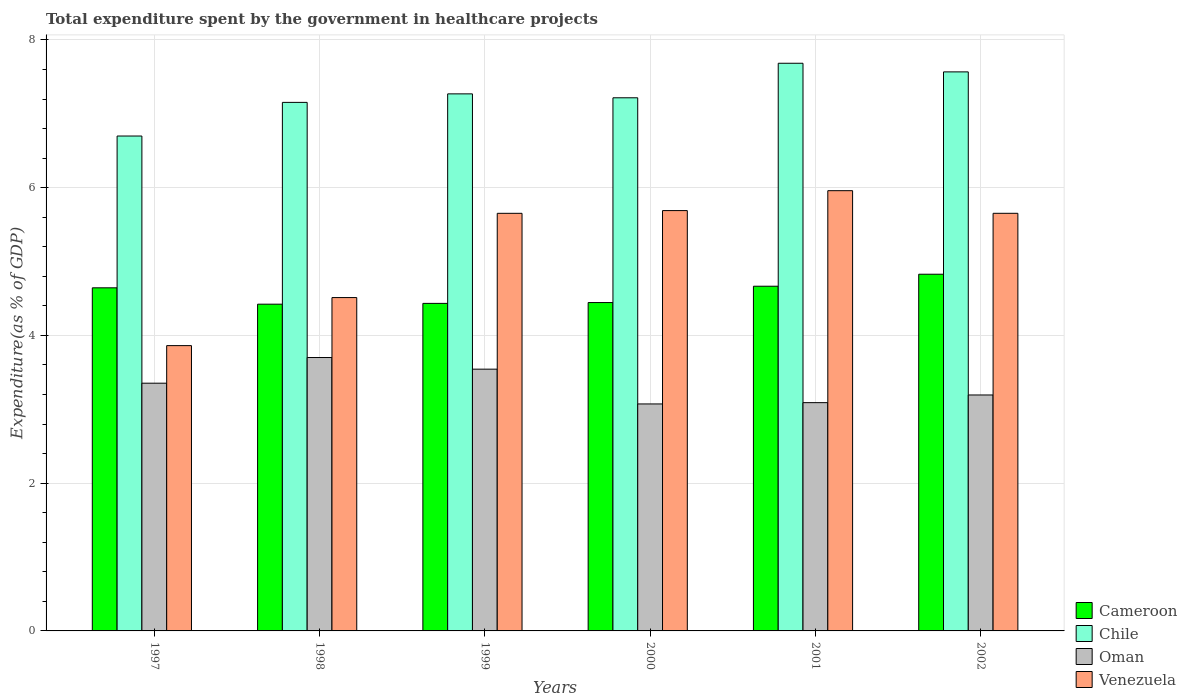How many different coloured bars are there?
Ensure brevity in your answer.  4. How many groups of bars are there?
Keep it short and to the point. 6. Are the number of bars on each tick of the X-axis equal?
Your response must be concise. Yes. How many bars are there on the 6th tick from the left?
Offer a very short reply. 4. In how many cases, is the number of bars for a given year not equal to the number of legend labels?
Keep it short and to the point. 0. What is the total expenditure spent by the government in healthcare projects in Chile in 1997?
Keep it short and to the point. 6.7. Across all years, what is the maximum total expenditure spent by the government in healthcare projects in Chile?
Make the answer very short. 7.68. Across all years, what is the minimum total expenditure spent by the government in healthcare projects in Venezuela?
Ensure brevity in your answer.  3.86. In which year was the total expenditure spent by the government in healthcare projects in Oman maximum?
Give a very brief answer. 1998. What is the total total expenditure spent by the government in healthcare projects in Chile in the graph?
Make the answer very short. 43.6. What is the difference between the total expenditure spent by the government in healthcare projects in Oman in 1998 and that in 2000?
Your answer should be compact. 0.63. What is the difference between the total expenditure spent by the government in healthcare projects in Chile in 2000 and the total expenditure spent by the government in healthcare projects in Oman in 1999?
Your answer should be very brief. 3.67. What is the average total expenditure spent by the government in healthcare projects in Chile per year?
Your answer should be compact. 7.27. In the year 2002, what is the difference between the total expenditure spent by the government in healthcare projects in Chile and total expenditure spent by the government in healthcare projects in Oman?
Provide a succinct answer. 4.37. In how many years, is the total expenditure spent by the government in healthcare projects in Chile greater than 1.2000000000000002 %?
Make the answer very short. 6. What is the ratio of the total expenditure spent by the government in healthcare projects in Venezuela in 1998 to that in 1999?
Give a very brief answer. 0.8. What is the difference between the highest and the second highest total expenditure spent by the government in healthcare projects in Chile?
Offer a terse response. 0.12. What is the difference between the highest and the lowest total expenditure spent by the government in healthcare projects in Venezuela?
Make the answer very short. 2.1. In how many years, is the total expenditure spent by the government in healthcare projects in Chile greater than the average total expenditure spent by the government in healthcare projects in Chile taken over all years?
Offer a very short reply. 3. Is it the case that in every year, the sum of the total expenditure spent by the government in healthcare projects in Venezuela and total expenditure spent by the government in healthcare projects in Cameroon is greater than the sum of total expenditure spent by the government in healthcare projects in Oman and total expenditure spent by the government in healthcare projects in Chile?
Offer a very short reply. Yes. What does the 4th bar from the left in 1997 represents?
Provide a short and direct response. Venezuela. What does the 3rd bar from the right in 2000 represents?
Make the answer very short. Chile. Is it the case that in every year, the sum of the total expenditure spent by the government in healthcare projects in Oman and total expenditure spent by the government in healthcare projects in Chile is greater than the total expenditure spent by the government in healthcare projects in Venezuela?
Make the answer very short. Yes. How many bars are there?
Keep it short and to the point. 24. What is the difference between two consecutive major ticks on the Y-axis?
Your response must be concise. 2. Are the values on the major ticks of Y-axis written in scientific E-notation?
Your response must be concise. No. Does the graph contain grids?
Offer a terse response. Yes. How are the legend labels stacked?
Give a very brief answer. Vertical. What is the title of the graph?
Your response must be concise. Total expenditure spent by the government in healthcare projects. Does "Portugal" appear as one of the legend labels in the graph?
Make the answer very short. No. What is the label or title of the Y-axis?
Keep it short and to the point. Expenditure(as % of GDP). What is the Expenditure(as % of GDP) of Cameroon in 1997?
Your answer should be very brief. 4.64. What is the Expenditure(as % of GDP) of Chile in 1997?
Offer a very short reply. 6.7. What is the Expenditure(as % of GDP) in Oman in 1997?
Provide a succinct answer. 3.35. What is the Expenditure(as % of GDP) of Venezuela in 1997?
Your answer should be very brief. 3.86. What is the Expenditure(as % of GDP) of Cameroon in 1998?
Ensure brevity in your answer.  4.42. What is the Expenditure(as % of GDP) in Chile in 1998?
Ensure brevity in your answer.  7.16. What is the Expenditure(as % of GDP) of Oman in 1998?
Provide a short and direct response. 3.7. What is the Expenditure(as % of GDP) of Venezuela in 1998?
Make the answer very short. 4.51. What is the Expenditure(as % of GDP) in Cameroon in 1999?
Offer a terse response. 4.43. What is the Expenditure(as % of GDP) in Chile in 1999?
Ensure brevity in your answer.  7.27. What is the Expenditure(as % of GDP) of Oman in 1999?
Offer a terse response. 3.54. What is the Expenditure(as % of GDP) in Venezuela in 1999?
Ensure brevity in your answer.  5.65. What is the Expenditure(as % of GDP) of Cameroon in 2000?
Keep it short and to the point. 4.45. What is the Expenditure(as % of GDP) in Chile in 2000?
Provide a short and direct response. 7.22. What is the Expenditure(as % of GDP) of Oman in 2000?
Ensure brevity in your answer.  3.07. What is the Expenditure(as % of GDP) of Venezuela in 2000?
Offer a very short reply. 5.69. What is the Expenditure(as % of GDP) of Cameroon in 2001?
Provide a short and direct response. 4.67. What is the Expenditure(as % of GDP) of Chile in 2001?
Your answer should be very brief. 7.68. What is the Expenditure(as % of GDP) in Oman in 2001?
Offer a terse response. 3.09. What is the Expenditure(as % of GDP) in Venezuela in 2001?
Your answer should be compact. 5.96. What is the Expenditure(as % of GDP) in Cameroon in 2002?
Make the answer very short. 4.83. What is the Expenditure(as % of GDP) in Chile in 2002?
Your response must be concise. 7.57. What is the Expenditure(as % of GDP) of Oman in 2002?
Provide a short and direct response. 3.19. What is the Expenditure(as % of GDP) of Venezuela in 2002?
Offer a terse response. 5.65. Across all years, what is the maximum Expenditure(as % of GDP) in Cameroon?
Provide a short and direct response. 4.83. Across all years, what is the maximum Expenditure(as % of GDP) in Chile?
Provide a succinct answer. 7.68. Across all years, what is the maximum Expenditure(as % of GDP) of Oman?
Your answer should be compact. 3.7. Across all years, what is the maximum Expenditure(as % of GDP) in Venezuela?
Your answer should be very brief. 5.96. Across all years, what is the minimum Expenditure(as % of GDP) in Cameroon?
Your answer should be very brief. 4.42. Across all years, what is the minimum Expenditure(as % of GDP) in Chile?
Your answer should be compact. 6.7. Across all years, what is the minimum Expenditure(as % of GDP) of Oman?
Make the answer very short. 3.07. Across all years, what is the minimum Expenditure(as % of GDP) in Venezuela?
Your answer should be very brief. 3.86. What is the total Expenditure(as % of GDP) in Cameroon in the graph?
Your answer should be compact. 27.44. What is the total Expenditure(as % of GDP) of Chile in the graph?
Provide a succinct answer. 43.6. What is the total Expenditure(as % of GDP) in Oman in the graph?
Ensure brevity in your answer.  19.96. What is the total Expenditure(as % of GDP) of Venezuela in the graph?
Offer a very short reply. 31.33. What is the difference between the Expenditure(as % of GDP) of Cameroon in 1997 and that in 1998?
Keep it short and to the point. 0.22. What is the difference between the Expenditure(as % of GDP) of Chile in 1997 and that in 1998?
Offer a very short reply. -0.46. What is the difference between the Expenditure(as % of GDP) of Oman in 1997 and that in 1998?
Provide a succinct answer. -0.35. What is the difference between the Expenditure(as % of GDP) of Venezuela in 1997 and that in 1998?
Give a very brief answer. -0.65. What is the difference between the Expenditure(as % of GDP) of Cameroon in 1997 and that in 1999?
Your answer should be very brief. 0.21. What is the difference between the Expenditure(as % of GDP) in Chile in 1997 and that in 1999?
Make the answer very short. -0.57. What is the difference between the Expenditure(as % of GDP) of Oman in 1997 and that in 1999?
Give a very brief answer. -0.19. What is the difference between the Expenditure(as % of GDP) in Venezuela in 1997 and that in 1999?
Ensure brevity in your answer.  -1.79. What is the difference between the Expenditure(as % of GDP) of Cameroon in 1997 and that in 2000?
Give a very brief answer. 0.2. What is the difference between the Expenditure(as % of GDP) in Chile in 1997 and that in 2000?
Ensure brevity in your answer.  -0.52. What is the difference between the Expenditure(as % of GDP) in Oman in 1997 and that in 2000?
Give a very brief answer. 0.28. What is the difference between the Expenditure(as % of GDP) in Venezuela in 1997 and that in 2000?
Your answer should be very brief. -1.83. What is the difference between the Expenditure(as % of GDP) of Cameroon in 1997 and that in 2001?
Your answer should be compact. -0.02. What is the difference between the Expenditure(as % of GDP) in Chile in 1997 and that in 2001?
Make the answer very short. -0.99. What is the difference between the Expenditure(as % of GDP) of Oman in 1997 and that in 2001?
Your answer should be compact. 0.26. What is the difference between the Expenditure(as % of GDP) in Venezuela in 1997 and that in 2001?
Your answer should be very brief. -2.1. What is the difference between the Expenditure(as % of GDP) in Cameroon in 1997 and that in 2002?
Ensure brevity in your answer.  -0.18. What is the difference between the Expenditure(as % of GDP) in Chile in 1997 and that in 2002?
Your response must be concise. -0.87. What is the difference between the Expenditure(as % of GDP) of Oman in 1997 and that in 2002?
Your answer should be very brief. 0.16. What is the difference between the Expenditure(as % of GDP) in Venezuela in 1997 and that in 2002?
Offer a terse response. -1.79. What is the difference between the Expenditure(as % of GDP) in Cameroon in 1998 and that in 1999?
Provide a short and direct response. -0.01. What is the difference between the Expenditure(as % of GDP) in Chile in 1998 and that in 1999?
Provide a succinct answer. -0.12. What is the difference between the Expenditure(as % of GDP) in Oman in 1998 and that in 1999?
Make the answer very short. 0.16. What is the difference between the Expenditure(as % of GDP) of Venezuela in 1998 and that in 1999?
Give a very brief answer. -1.14. What is the difference between the Expenditure(as % of GDP) of Cameroon in 1998 and that in 2000?
Give a very brief answer. -0.02. What is the difference between the Expenditure(as % of GDP) in Chile in 1998 and that in 2000?
Your response must be concise. -0.06. What is the difference between the Expenditure(as % of GDP) of Oman in 1998 and that in 2000?
Your response must be concise. 0.63. What is the difference between the Expenditure(as % of GDP) in Venezuela in 1998 and that in 2000?
Provide a succinct answer. -1.18. What is the difference between the Expenditure(as % of GDP) of Cameroon in 1998 and that in 2001?
Make the answer very short. -0.24. What is the difference between the Expenditure(as % of GDP) in Chile in 1998 and that in 2001?
Keep it short and to the point. -0.53. What is the difference between the Expenditure(as % of GDP) in Oman in 1998 and that in 2001?
Your answer should be very brief. 0.61. What is the difference between the Expenditure(as % of GDP) of Venezuela in 1998 and that in 2001?
Offer a terse response. -1.45. What is the difference between the Expenditure(as % of GDP) of Cameroon in 1998 and that in 2002?
Offer a very short reply. -0.41. What is the difference between the Expenditure(as % of GDP) in Chile in 1998 and that in 2002?
Offer a terse response. -0.41. What is the difference between the Expenditure(as % of GDP) in Oman in 1998 and that in 2002?
Offer a terse response. 0.51. What is the difference between the Expenditure(as % of GDP) in Venezuela in 1998 and that in 2002?
Make the answer very short. -1.14. What is the difference between the Expenditure(as % of GDP) of Cameroon in 1999 and that in 2000?
Give a very brief answer. -0.01. What is the difference between the Expenditure(as % of GDP) of Chile in 1999 and that in 2000?
Provide a succinct answer. 0.05. What is the difference between the Expenditure(as % of GDP) of Oman in 1999 and that in 2000?
Provide a succinct answer. 0.47. What is the difference between the Expenditure(as % of GDP) of Venezuela in 1999 and that in 2000?
Give a very brief answer. -0.04. What is the difference between the Expenditure(as % of GDP) in Cameroon in 1999 and that in 2001?
Give a very brief answer. -0.23. What is the difference between the Expenditure(as % of GDP) of Chile in 1999 and that in 2001?
Provide a short and direct response. -0.41. What is the difference between the Expenditure(as % of GDP) of Oman in 1999 and that in 2001?
Your answer should be compact. 0.45. What is the difference between the Expenditure(as % of GDP) of Venezuela in 1999 and that in 2001?
Keep it short and to the point. -0.31. What is the difference between the Expenditure(as % of GDP) of Cameroon in 1999 and that in 2002?
Your answer should be compact. -0.39. What is the difference between the Expenditure(as % of GDP) in Chile in 1999 and that in 2002?
Provide a succinct answer. -0.3. What is the difference between the Expenditure(as % of GDP) in Oman in 1999 and that in 2002?
Your answer should be very brief. 0.35. What is the difference between the Expenditure(as % of GDP) of Venezuela in 1999 and that in 2002?
Make the answer very short. -0. What is the difference between the Expenditure(as % of GDP) of Cameroon in 2000 and that in 2001?
Provide a short and direct response. -0.22. What is the difference between the Expenditure(as % of GDP) of Chile in 2000 and that in 2001?
Provide a short and direct response. -0.47. What is the difference between the Expenditure(as % of GDP) in Oman in 2000 and that in 2001?
Give a very brief answer. -0.02. What is the difference between the Expenditure(as % of GDP) of Venezuela in 2000 and that in 2001?
Your response must be concise. -0.27. What is the difference between the Expenditure(as % of GDP) in Cameroon in 2000 and that in 2002?
Your answer should be very brief. -0.38. What is the difference between the Expenditure(as % of GDP) of Chile in 2000 and that in 2002?
Keep it short and to the point. -0.35. What is the difference between the Expenditure(as % of GDP) of Oman in 2000 and that in 2002?
Offer a very short reply. -0.12. What is the difference between the Expenditure(as % of GDP) in Venezuela in 2000 and that in 2002?
Ensure brevity in your answer.  0.04. What is the difference between the Expenditure(as % of GDP) in Cameroon in 2001 and that in 2002?
Offer a very short reply. -0.16. What is the difference between the Expenditure(as % of GDP) in Chile in 2001 and that in 2002?
Make the answer very short. 0.12. What is the difference between the Expenditure(as % of GDP) of Oman in 2001 and that in 2002?
Offer a very short reply. -0.1. What is the difference between the Expenditure(as % of GDP) of Venezuela in 2001 and that in 2002?
Ensure brevity in your answer.  0.31. What is the difference between the Expenditure(as % of GDP) in Cameroon in 1997 and the Expenditure(as % of GDP) in Chile in 1998?
Your response must be concise. -2.51. What is the difference between the Expenditure(as % of GDP) of Cameroon in 1997 and the Expenditure(as % of GDP) of Oman in 1998?
Ensure brevity in your answer.  0.94. What is the difference between the Expenditure(as % of GDP) in Cameroon in 1997 and the Expenditure(as % of GDP) in Venezuela in 1998?
Make the answer very short. 0.13. What is the difference between the Expenditure(as % of GDP) in Chile in 1997 and the Expenditure(as % of GDP) in Oman in 1998?
Keep it short and to the point. 3. What is the difference between the Expenditure(as % of GDP) of Chile in 1997 and the Expenditure(as % of GDP) of Venezuela in 1998?
Ensure brevity in your answer.  2.19. What is the difference between the Expenditure(as % of GDP) in Oman in 1997 and the Expenditure(as % of GDP) in Venezuela in 1998?
Offer a very short reply. -1.16. What is the difference between the Expenditure(as % of GDP) of Cameroon in 1997 and the Expenditure(as % of GDP) of Chile in 1999?
Offer a terse response. -2.63. What is the difference between the Expenditure(as % of GDP) of Cameroon in 1997 and the Expenditure(as % of GDP) of Oman in 1999?
Keep it short and to the point. 1.1. What is the difference between the Expenditure(as % of GDP) of Cameroon in 1997 and the Expenditure(as % of GDP) of Venezuela in 1999?
Provide a succinct answer. -1.01. What is the difference between the Expenditure(as % of GDP) of Chile in 1997 and the Expenditure(as % of GDP) of Oman in 1999?
Give a very brief answer. 3.16. What is the difference between the Expenditure(as % of GDP) in Chile in 1997 and the Expenditure(as % of GDP) in Venezuela in 1999?
Your answer should be very brief. 1.05. What is the difference between the Expenditure(as % of GDP) of Oman in 1997 and the Expenditure(as % of GDP) of Venezuela in 1999?
Ensure brevity in your answer.  -2.3. What is the difference between the Expenditure(as % of GDP) in Cameroon in 1997 and the Expenditure(as % of GDP) in Chile in 2000?
Ensure brevity in your answer.  -2.57. What is the difference between the Expenditure(as % of GDP) in Cameroon in 1997 and the Expenditure(as % of GDP) in Oman in 2000?
Give a very brief answer. 1.57. What is the difference between the Expenditure(as % of GDP) in Cameroon in 1997 and the Expenditure(as % of GDP) in Venezuela in 2000?
Offer a very short reply. -1.05. What is the difference between the Expenditure(as % of GDP) of Chile in 1997 and the Expenditure(as % of GDP) of Oman in 2000?
Keep it short and to the point. 3.63. What is the difference between the Expenditure(as % of GDP) in Chile in 1997 and the Expenditure(as % of GDP) in Venezuela in 2000?
Your response must be concise. 1.01. What is the difference between the Expenditure(as % of GDP) in Oman in 1997 and the Expenditure(as % of GDP) in Venezuela in 2000?
Offer a very short reply. -2.34. What is the difference between the Expenditure(as % of GDP) of Cameroon in 1997 and the Expenditure(as % of GDP) of Chile in 2001?
Offer a terse response. -3.04. What is the difference between the Expenditure(as % of GDP) of Cameroon in 1997 and the Expenditure(as % of GDP) of Oman in 2001?
Your answer should be very brief. 1.55. What is the difference between the Expenditure(as % of GDP) of Cameroon in 1997 and the Expenditure(as % of GDP) of Venezuela in 2001?
Provide a short and direct response. -1.32. What is the difference between the Expenditure(as % of GDP) of Chile in 1997 and the Expenditure(as % of GDP) of Oman in 2001?
Your answer should be compact. 3.61. What is the difference between the Expenditure(as % of GDP) in Chile in 1997 and the Expenditure(as % of GDP) in Venezuela in 2001?
Ensure brevity in your answer.  0.74. What is the difference between the Expenditure(as % of GDP) in Oman in 1997 and the Expenditure(as % of GDP) in Venezuela in 2001?
Provide a succinct answer. -2.61. What is the difference between the Expenditure(as % of GDP) in Cameroon in 1997 and the Expenditure(as % of GDP) in Chile in 2002?
Your response must be concise. -2.92. What is the difference between the Expenditure(as % of GDP) of Cameroon in 1997 and the Expenditure(as % of GDP) of Oman in 2002?
Offer a very short reply. 1.45. What is the difference between the Expenditure(as % of GDP) in Cameroon in 1997 and the Expenditure(as % of GDP) in Venezuela in 2002?
Make the answer very short. -1.01. What is the difference between the Expenditure(as % of GDP) of Chile in 1997 and the Expenditure(as % of GDP) of Oman in 2002?
Your answer should be very brief. 3.51. What is the difference between the Expenditure(as % of GDP) of Chile in 1997 and the Expenditure(as % of GDP) of Venezuela in 2002?
Your response must be concise. 1.05. What is the difference between the Expenditure(as % of GDP) in Oman in 1997 and the Expenditure(as % of GDP) in Venezuela in 2002?
Provide a succinct answer. -2.3. What is the difference between the Expenditure(as % of GDP) of Cameroon in 1998 and the Expenditure(as % of GDP) of Chile in 1999?
Your answer should be very brief. -2.85. What is the difference between the Expenditure(as % of GDP) in Cameroon in 1998 and the Expenditure(as % of GDP) in Oman in 1999?
Provide a succinct answer. 0.88. What is the difference between the Expenditure(as % of GDP) in Cameroon in 1998 and the Expenditure(as % of GDP) in Venezuela in 1999?
Offer a terse response. -1.23. What is the difference between the Expenditure(as % of GDP) in Chile in 1998 and the Expenditure(as % of GDP) in Oman in 1999?
Keep it short and to the point. 3.61. What is the difference between the Expenditure(as % of GDP) of Chile in 1998 and the Expenditure(as % of GDP) of Venezuela in 1999?
Your answer should be compact. 1.5. What is the difference between the Expenditure(as % of GDP) in Oman in 1998 and the Expenditure(as % of GDP) in Venezuela in 1999?
Make the answer very short. -1.95. What is the difference between the Expenditure(as % of GDP) in Cameroon in 1998 and the Expenditure(as % of GDP) in Chile in 2000?
Your answer should be very brief. -2.79. What is the difference between the Expenditure(as % of GDP) of Cameroon in 1998 and the Expenditure(as % of GDP) of Oman in 2000?
Your answer should be compact. 1.35. What is the difference between the Expenditure(as % of GDP) in Cameroon in 1998 and the Expenditure(as % of GDP) in Venezuela in 2000?
Offer a terse response. -1.27. What is the difference between the Expenditure(as % of GDP) in Chile in 1998 and the Expenditure(as % of GDP) in Oman in 2000?
Offer a very short reply. 4.08. What is the difference between the Expenditure(as % of GDP) in Chile in 1998 and the Expenditure(as % of GDP) in Venezuela in 2000?
Offer a very short reply. 1.46. What is the difference between the Expenditure(as % of GDP) of Oman in 1998 and the Expenditure(as % of GDP) of Venezuela in 2000?
Your response must be concise. -1.99. What is the difference between the Expenditure(as % of GDP) of Cameroon in 1998 and the Expenditure(as % of GDP) of Chile in 2001?
Offer a very short reply. -3.26. What is the difference between the Expenditure(as % of GDP) in Cameroon in 1998 and the Expenditure(as % of GDP) in Oman in 2001?
Make the answer very short. 1.33. What is the difference between the Expenditure(as % of GDP) of Cameroon in 1998 and the Expenditure(as % of GDP) of Venezuela in 2001?
Offer a very short reply. -1.54. What is the difference between the Expenditure(as % of GDP) of Chile in 1998 and the Expenditure(as % of GDP) of Oman in 2001?
Your answer should be compact. 4.06. What is the difference between the Expenditure(as % of GDP) in Chile in 1998 and the Expenditure(as % of GDP) in Venezuela in 2001?
Your answer should be compact. 1.2. What is the difference between the Expenditure(as % of GDP) of Oman in 1998 and the Expenditure(as % of GDP) of Venezuela in 2001?
Ensure brevity in your answer.  -2.26. What is the difference between the Expenditure(as % of GDP) of Cameroon in 1998 and the Expenditure(as % of GDP) of Chile in 2002?
Keep it short and to the point. -3.14. What is the difference between the Expenditure(as % of GDP) of Cameroon in 1998 and the Expenditure(as % of GDP) of Oman in 2002?
Offer a very short reply. 1.23. What is the difference between the Expenditure(as % of GDP) of Cameroon in 1998 and the Expenditure(as % of GDP) of Venezuela in 2002?
Ensure brevity in your answer.  -1.23. What is the difference between the Expenditure(as % of GDP) of Chile in 1998 and the Expenditure(as % of GDP) of Oman in 2002?
Ensure brevity in your answer.  3.96. What is the difference between the Expenditure(as % of GDP) in Chile in 1998 and the Expenditure(as % of GDP) in Venezuela in 2002?
Your response must be concise. 1.5. What is the difference between the Expenditure(as % of GDP) of Oman in 1998 and the Expenditure(as % of GDP) of Venezuela in 2002?
Ensure brevity in your answer.  -1.95. What is the difference between the Expenditure(as % of GDP) of Cameroon in 1999 and the Expenditure(as % of GDP) of Chile in 2000?
Make the answer very short. -2.78. What is the difference between the Expenditure(as % of GDP) of Cameroon in 1999 and the Expenditure(as % of GDP) of Oman in 2000?
Offer a very short reply. 1.36. What is the difference between the Expenditure(as % of GDP) in Cameroon in 1999 and the Expenditure(as % of GDP) in Venezuela in 2000?
Your answer should be very brief. -1.26. What is the difference between the Expenditure(as % of GDP) in Chile in 1999 and the Expenditure(as % of GDP) in Oman in 2000?
Offer a very short reply. 4.2. What is the difference between the Expenditure(as % of GDP) of Chile in 1999 and the Expenditure(as % of GDP) of Venezuela in 2000?
Ensure brevity in your answer.  1.58. What is the difference between the Expenditure(as % of GDP) of Oman in 1999 and the Expenditure(as % of GDP) of Venezuela in 2000?
Your response must be concise. -2.15. What is the difference between the Expenditure(as % of GDP) in Cameroon in 1999 and the Expenditure(as % of GDP) in Chile in 2001?
Your answer should be very brief. -3.25. What is the difference between the Expenditure(as % of GDP) in Cameroon in 1999 and the Expenditure(as % of GDP) in Oman in 2001?
Keep it short and to the point. 1.34. What is the difference between the Expenditure(as % of GDP) in Cameroon in 1999 and the Expenditure(as % of GDP) in Venezuela in 2001?
Offer a terse response. -1.53. What is the difference between the Expenditure(as % of GDP) of Chile in 1999 and the Expenditure(as % of GDP) of Oman in 2001?
Offer a very short reply. 4.18. What is the difference between the Expenditure(as % of GDP) of Chile in 1999 and the Expenditure(as % of GDP) of Venezuela in 2001?
Provide a short and direct response. 1.31. What is the difference between the Expenditure(as % of GDP) of Oman in 1999 and the Expenditure(as % of GDP) of Venezuela in 2001?
Your response must be concise. -2.42. What is the difference between the Expenditure(as % of GDP) in Cameroon in 1999 and the Expenditure(as % of GDP) in Chile in 2002?
Ensure brevity in your answer.  -3.13. What is the difference between the Expenditure(as % of GDP) in Cameroon in 1999 and the Expenditure(as % of GDP) in Oman in 2002?
Give a very brief answer. 1.24. What is the difference between the Expenditure(as % of GDP) in Cameroon in 1999 and the Expenditure(as % of GDP) in Venezuela in 2002?
Keep it short and to the point. -1.22. What is the difference between the Expenditure(as % of GDP) of Chile in 1999 and the Expenditure(as % of GDP) of Oman in 2002?
Ensure brevity in your answer.  4.08. What is the difference between the Expenditure(as % of GDP) in Chile in 1999 and the Expenditure(as % of GDP) in Venezuela in 2002?
Your response must be concise. 1.62. What is the difference between the Expenditure(as % of GDP) of Oman in 1999 and the Expenditure(as % of GDP) of Venezuela in 2002?
Offer a terse response. -2.11. What is the difference between the Expenditure(as % of GDP) of Cameroon in 2000 and the Expenditure(as % of GDP) of Chile in 2001?
Offer a terse response. -3.24. What is the difference between the Expenditure(as % of GDP) in Cameroon in 2000 and the Expenditure(as % of GDP) in Oman in 2001?
Your answer should be very brief. 1.35. What is the difference between the Expenditure(as % of GDP) of Cameroon in 2000 and the Expenditure(as % of GDP) of Venezuela in 2001?
Offer a terse response. -1.51. What is the difference between the Expenditure(as % of GDP) of Chile in 2000 and the Expenditure(as % of GDP) of Oman in 2001?
Your response must be concise. 4.13. What is the difference between the Expenditure(as % of GDP) of Chile in 2000 and the Expenditure(as % of GDP) of Venezuela in 2001?
Your answer should be very brief. 1.26. What is the difference between the Expenditure(as % of GDP) of Oman in 2000 and the Expenditure(as % of GDP) of Venezuela in 2001?
Your answer should be very brief. -2.89. What is the difference between the Expenditure(as % of GDP) in Cameroon in 2000 and the Expenditure(as % of GDP) in Chile in 2002?
Provide a succinct answer. -3.12. What is the difference between the Expenditure(as % of GDP) of Cameroon in 2000 and the Expenditure(as % of GDP) of Oman in 2002?
Your response must be concise. 1.25. What is the difference between the Expenditure(as % of GDP) in Cameroon in 2000 and the Expenditure(as % of GDP) in Venezuela in 2002?
Provide a succinct answer. -1.21. What is the difference between the Expenditure(as % of GDP) in Chile in 2000 and the Expenditure(as % of GDP) in Oman in 2002?
Provide a short and direct response. 4.02. What is the difference between the Expenditure(as % of GDP) in Chile in 2000 and the Expenditure(as % of GDP) in Venezuela in 2002?
Ensure brevity in your answer.  1.56. What is the difference between the Expenditure(as % of GDP) in Oman in 2000 and the Expenditure(as % of GDP) in Venezuela in 2002?
Your answer should be very brief. -2.58. What is the difference between the Expenditure(as % of GDP) of Cameroon in 2001 and the Expenditure(as % of GDP) of Chile in 2002?
Your response must be concise. -2.9. What is the difference between the Expenditure(as % of GDP) of Cameroon in 2001 and the Expenditure(as % of GDP) of Oman in 2002?
Provide a succinct answer. 1.47. What is the difference between the Expenditure(as % of GDP) in Cameroon in 2001 and the Expenditure(as % of GDP) in Venezuela in 2002?
Your response must be concise. -0.99. What is the difference between the Expenditure(as % of GDP) in Chile in 2001 and the Expenditure(as % of GDP) in Oman in 2002?
Offer a very short reply. 4.49. What is the difference between the Expenditure(as % of GDP) in Chile in 2001 and the Expenditure(as % of GDP) in Venezuela in 2002?
Your answer should be very brief. 2.03. What is the difference between the Expenditure(as % of GDP) in Oman in 2001 and the Expenditure(as % of GDP) in Venezuela in 2002?
Give a very brief answer. -2.56. What is the average Expenditure(as % of GDP) in Cameroon per year?
Provide a succinct answer. 4.57. What is the average Expenditure(as % of GDP) of Chile per year?
Keep it short and to the point. 7.27. What is the average Expenditure(as % of GDP) of Oman per year?
Give a very brief answer. 3.33. What is the average Expenditure(as % of GDP) of Venezuela per year?
Offer a terse response. 5.22. In the year 1997, what is the difference between the Expenditure(as % of GDP) of Cameroon and Expenditure(as % of GDP) of Chile?
Your answer should be very brief. -2.06. In the year 1997, what is the difference between the Expenditure(as % of GDP) in Cameroon and Expenditure(as % of GDP) in Oman?
Make the answer very short. 1.29. In the year 1997, what is the difference between the Expenditure(as % of GDP) in Cameroon and Expenditure(as % of GDP) in Venezuela?
Offer a very short reply. 0.78. In the year 1997, what is the difference between the Expenditure(as % of GDP) of Chile and Expenditure(as % of GDP) of Oman?
Offer a very short reply. 3.35. In the year 1997, what is the difference between the Expenditure(as % of GDP) of Chile and Expenditure(as % of GDP) of Venezuela?
Provide a succinct answer. 2.84. In the year 1997, what is the difference between the Expenditure(as % of GDP) in Oman and Expenditure(as % of GDP) in Venezuela?
Ensure brevity in your answer.  -0.51. In the year 1998, what is the difference between the Expenditure(as % of GDP) in Cameroon and Expenditure(as % of GDP) in Chile?
Your answer should be compact. -2.73. In the year 1998, what is the difference between the Expenditure(as % of GDP) of Cameroon and Expenditure(as % of GDP) of Oman?
Give a very brief answer. 0.72. In the year 1998, what is the difference between the Expenditure(as % of GDP) of Cameroon and Expenditure(as % of GDP) of Venezuela?
Provide a succinct answer. -0.09. In the year 1998, what is the difference between the Expenditure(as % of GDP) in Chile and Expenditure(as % of GDP) in Oman?
Keep it short and to the point. 3.45. In the year 1998, what is the difference between the Expenditure(as % of GDP) of Chile and Expenditure(as % of GDP) of Venezuela?
Ensure brevity in your answer.  2.64. In the year 1998, what is the difference between the Expenditure(as % of GDP) in Oman and Expenditure(as % of GDP) in Venezuela?
Offer a very short reply. -0.81. In the year 1999, what is the difference between the Expenditure(as % of GDP) of Cameroon and Expenditure(as % of GDP) of Chile?
Your answer should be very brief. -2.84. In the year 1999, what is the difference between the Expenditure(as % of GDP) in Cameroon and Expenditure(as % of GDP) in Oman?
Your answer should be very brief. 0.89. In the year 1999, what is the difference between the Expenditure(as % of GDP) in Cameroon and Expenditure(as % of GDP) in Venezuela?
Give a very brief answer. -1.22. In the year 1999, what is the difference between the Expenditure(as % of GDP) in Chile and Expenditure(as % of GDP) in Oman?
Your response must be concise. 3.73. In the year 1999, what is the difference between the Expenditure(as % of GDP) of Chile and Expenditure(as % of GDP) of Venezuela?
Provide a succinct answer. 1.62. In the year 1999, what is the difference between the Expenditure(as % of GDP) of Oman and Expenditure(as % of GDP) of Venezuela?
Give a very brief answer. -2.11. In the year 2000, what is the difference between the Expenditure(as % of GDP) of Cameroon and Expenditure(as % of GDP) of Chile?
Provide a short and direct response. -2.77. In the year 2000, what is the difference between the Expenditure(as % of GDP) in Cameroon and Expenditure(as % of GDP) in Oman?
Provide a short and direct response. 1.37. In the year 2000, what is the difference between the Expenditure(as % of GDP) of Cameroon and Expenditure(as % of GDP) of Venezuela?
Provide a succinct answer. -1.25. In the year 2000, what is the difference between the Expenditure(as % of GDP) in Chile and Expenditure(as % of GDP) in Oman?
Provide a succinct answer. 4.14. In the year 2000, what is the difference between the Expenditure(as % of GDP) in Chile and Expenditure(as % of GDP) in Venezuela?
Your answer should be very brief. 1.53. In the year 2000, what is the difference between the Expenditure(as % of GDP) of Oman and Expenditure(as % of GDP) of Venezuela?
Give a very brief answer. -2.62. In the year 2001, what is the difference between the Expenditure(as % of GDP) in Cameroon and Expenditure(as % of GDP) in Chile?
Give a very brief answer. -3.02. In the year 2001, what is the difference between the Expenditure(as % of GDP) in Cameroon and Expenditure(as % of GDP) in Oman?
Provide a succinct answer. 1.58. In the year 2001, what is the difference between the Expenditure(as % of GDP) of Cameroon and Expenditure(as % of GDP) of Venezuela?
Provide a succinct answer. -1.29. In the year 2001, what is the difference between the Expenditure(as % of GDP) of Chile and Expenditure(as % of GDP) of Oman?
Keep it short and to the point. 4.59. In the year 2001, what is the difference between the Expenditure(as % of GDP) of Chile and Expenditure(as % of GDP) of Venezuela?
Make the answer very short. 1.73. In the year 2001, what is the difference between the Expenditure(as % of GDP) in Oman and Expenditure(as % of GDP) in Venezuela?
Give a very brief answer. -2.87. In the year 2002, what is the difference between the Expenditure(as % of GDP) of Cameroon and Expenditure(as % of GDP) of Chile?
Make the answer very short. -2.74. In the year 2002, what is the difference between the Expenditure(as % of GDP) in Cameroon and Expenditure(as % of GDP) in Oman?
Ensure brevity in your answer.  1.63. In the year 2002, what is the difference between the Expenditure(as % of GDP) of Cameroon and Expenditure(as % of GDP) of Venezuela?
Provide a short and direct response. -0.82. In the year 2002, what is the difference between the Expenditure(as % of GDP) of Chile and Expenditure(as % of GDP) of Oman?
Your response must be concise. 4.37. In the year 2002, what is the difference between the Expenditure(as % of GDP) of Chile and Expenditure(as % of GDP) of Venezuela?
Provide a short and direct response. 1.91. In the year 2002, what is the difference between the Expenditure(as % of GDP) of Oman and Expenditure(as % of GDP) of Venezuela?
Offer a terse response. -2.46. What is the ratio of the Expenditure(as % of GDP) of Cameroon in 1997 to that in 1998?
Offer a very short reply. 1.05. What is the ratio of the Expenditure(as % of GDP) in Chile in 1997 to that in 1998?
Provide a succinct answer. 0.94. What is the ratio of the Expenditure(as % of GDP) in Oman in 1997 to that in 1998?
Your answer should be compact. 0.91. What is the ratio of the Expenditure(as % of GDP) in Venezuela in 1997 to that in 1998?
Ensure brevity in your answer.  0.86. What is the ratio of the Expenditure(as % of GDP) of Cameroon in 1997 to that in 1999?
Keep it short and to the point. 1.05. What is the ratio of the Expenditure(as % of GDP) in Chile in 1997 to that in 1999?
Your answer should be very brief. 0.92. What is the ratio of the Expenditure(as % of GDP) in Oman in 1997 to that in 1999?
Give a very brief answer. 0.95. What is the ratio of the Expenditure(as % of GDP) in Venezuela in 1997 to that in 1999?
Your answer should be compact. 0.68. What is the ratio of the Expenditure(as % of GDP) of Cameroon in 1997 to that in 2000?
Make the answer very short. 1.04. What is the ratio of the Expenditure(as % of GDP) in Chile in 1997 to that in 2000?
Make the answer very short. 0.93. What is the ratio of the Expenditure(as % of GDP) in Oman in 1997 to that in 2000?
Give a very brief answer. 1.09. What is the ratio of the Expenditure(as % of GDP) in Venezuela in 1997 to that in 2000?
Keep it short and to the point. 0.68. What is the ratio of the Expenditure(as % of GDP) in Chile in 1997 to that in 2001?
Your answer should be compact. 0.87. What is the ratio of the Expenditure(as % of GDP) of Oman in 1997 to that in 2001?
Your answer should be very brief. 1.09. What is the ratio of the Expenditure(as % of GDP) in Venezuela in 1997 to that in 2001?
Offer a terse response. 0.65. What is the ratio of the Expenditure(as % of GDP) of Cameroon in 1997 to that in 2002?
Offer a very short reply. 0.96. What is the ratio of the Expenditure(as % of GDP) of Chile in 1997 to that in 2002?
Ensure brevity in your answer.  0.89. What is the ratio of the Expenditure(as % of GDP) in Oman in 1997 to that in 2002?
Give a very brief answer. 1.05. What is the ratio of the Expenditure(as % of GDP) in Venezuela in 1997 to that in 2002?
Offer a very short reply. 0.68. What is the ratio of the Expenditure(as % of GDP) in Chile in 1998 to that in 1999?
Ensure brevity in your answer.  0.98. What is the ratio of the Expenditure(as % of GDP) in Oman in 1998 to that in 1999?
Offer a terse response. 1.04. What is the ratio of the Expenditure(as % of GDP) of Venezuela in 1998 to that in 1999?
Provide a succinct answer. 0.8. What is the ratio of the Expenditure(as % of GDP) of Cameroon in 1998 to that in 2000?
Make the answer very short. 1. What is the ratio of the Expenditure(as % of GDP) in Oman in 1998 to that in 2000?
Ensure brevity in your answer.  1.2. What is the ratio of the Expenditure(as % of GDP) of Venezuela in 1998 to that in 2000?
Your response must be concise. 0.79. What is the ratio of the Expenditure(as % of GDP) of Cameroon in 1998 to that in 2001?
Give a very brief answer. 0.95. What is the ratio of the Expenditure(as % of GDP) of Chile in 1998 to that in 2001?
Make the answer very short. 0.93. What is the ratio of the Expenditure(as % of GDP) of Oman in 1998 to that in 2001?
Your answer should be compact. 1.2. What is the ratio of the Expenditure(as % of GDP) of Venezuela in 1998 to that in 2001?
Offer a terse response. 0.76. What is the ratio of the Expenditure(as % of GDP) in Cameroon in 1998 to that in 2002?
Ensure brevity in your answer.  0.92. What is the ratio of the Expenditure(as % of GDP) in Chile in 1998 to that in 2002?
Your answer should be compact. 0.95. What is the ratio of the Expenditure(as % of GDP) in Oman in 1998 to that in 2002?
Provide a short and direct response. 1.16. What is the ratio of the Expenditure(as % of GDP) in Venezuela in 1998 to that in 2002?
Provide a short and direct response. 0.8. What is the ratio of the Expenditure(as % of GDP) of Chile in 1999 to that in 2000?
Give a very brief answer. 1.01. What is the ratio of the Expenditure(as % of GDP) of Oman in 1999 to that in 2000?
Your answer should be compact. 1.15. What is the ratio of the Expenditure(as % of GDP) in Cameroon in 1999 to that in 2001?
Provide a succinct answer. 0.95. What is the ratio of the Expenditure(as % of GDP) of Chile in 1999 to that in 2001?
Make the answer very short. 0.95. What is the ratio of the Expenditure(as % of GDP) of Oman in 1999 to that in 2001?
Provide a short and direct response. 1.15. What is the ratio of the Expenditure(as % of GDP) of Venezuela in 1999 to that in 2001?
Offer a very short reply. 0.95. What is the ratio of the Expenditure(as % of GDP) in Cameroon in 1999 to that in 2002?
Your response must be concise. 0.92. What is the ratio of the Expenditure(as % of GDP) in Chile in 1999 to that in 2002?
Your response must be concise. 0.96. What is the ratio of the Expenditure(as % of GDP) in Oman in 1999 to that in 2002?
Your answer should be very brief. 1.11. What is the ratio of the Expenditure(as % of GDP) in Cameroon in 2000 to that in 2001?
Keep it short and to the point. 0.95. What is the ratio of the Expenditure(as % of GDP) in Chile in 2000 to that in 2001?
Offer a very short reply. 0.94. What is the ratio of the Expenditure(as % of GDP) of Venezuela in 2000 to that in 2001?
Make the answer very short. 0.95. What is the ratio of the Expenditure(as % of GDP) in Cameroon in 2000 to that in 2002?
Give a very brief answer. 0.92. What is the ratio of the Expenditure(as % of GDP) in Chile in 2000 to that in 2002?
Provide a succinct answer. 0.95. What is the ratio of the Expenditure(as % of GDP) of Oman in 2000 to that in 2002?
Provide a succinct answer. 0.96. What is the ratio of the Expenditure(as % of GDP) in Venezuela in 2000 to that in 2002?
Offer a terse response. 1.01. What is the ratio of the Expenditure(as % of GDP) in Cameroon in 2001 to that in 2002?
Your response must be concise. 0.97. What is the ratio of the Expenditure(as % of GDP) in Chile in 2001 to that in 2002?
Provide a short and direct response. 1.02. What is the ratio of the Expenditure(as % of GDP) in Oman in 2001 to that in 2002?
Your response must be concise. 0.97. What is the ratio of the Expenditure(as % of GDP) of Venezuela in 2001 to that in 2002?
Provide a short and direct response. 1.05. What is the difference between the highest and the second highest Expenditure(as % of GDP) in Cameroon?
Offer a very short reply. 0.16. What is the difference between the highest and the second highest Expenditure(as % of GDP) in Chile?
Provide a short and direct response. 0.12. What is the difference between the highest and the second highest Expenditure(as % of GDP) in Oman?
Your answer should be very brief. 0.16. What is the difference between the highest and the second highest Expenditure(as % of GDP) in Venezuela?
Provide a short and direct response. 0.27. What is the difference between the highest and the lowest Expenditure(as % of GDP) of Cameroon?
Give a very brief answer. 0.41. What is the difference between the highest and the lowest Expenditure(as % of GDP) of Chile?
Your response must be concise. 0.99. What is the difference between the highest and the lowest Expenditure(as % of GDP) of Oman?
Keep it short and to the point. 0.63. What is the difference between the highest and the lowest Expenditure(as % of GDP) of Venezuela?
Offer a terse response. 2.1. 